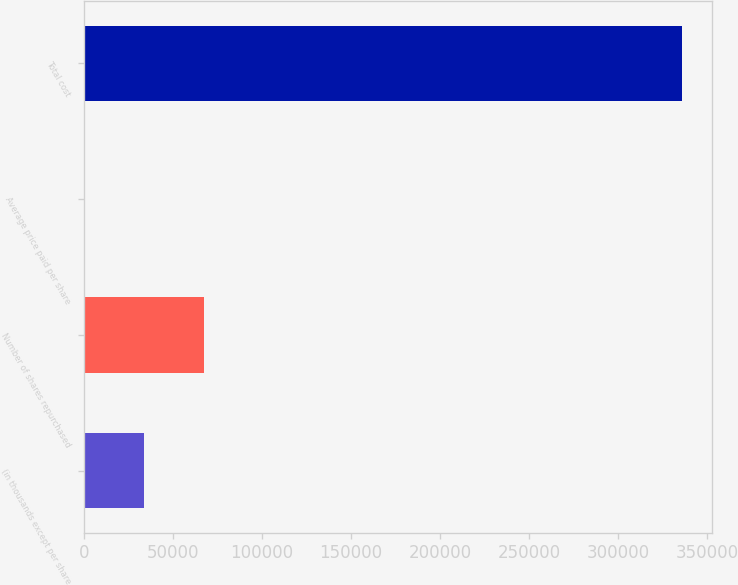<chart> <loc_0><loc_0><loc_500><loc_500><bar_chart><fcel>(in thousands except per share<fcel>Number of shares repurchased<fcel>Average price paid per share<fcel>Total cost<nl><fcel>33715.3<fcel>67339.7<fcel>90.9<fcel>336335<nl></chart> 